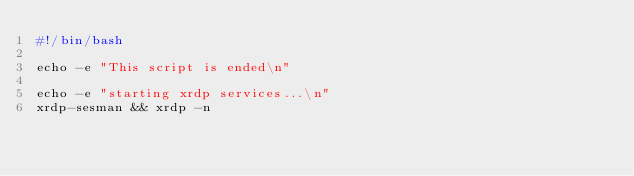Convert code to text. <code><loc_0><loc_0><loc_500><loc_500><_Bash_>#!/bin/bash

echo -e "This script is ended\n"

echo -e "starting xrdp services...\n"
xrdp-sesman && xrdp -n 



</code> 